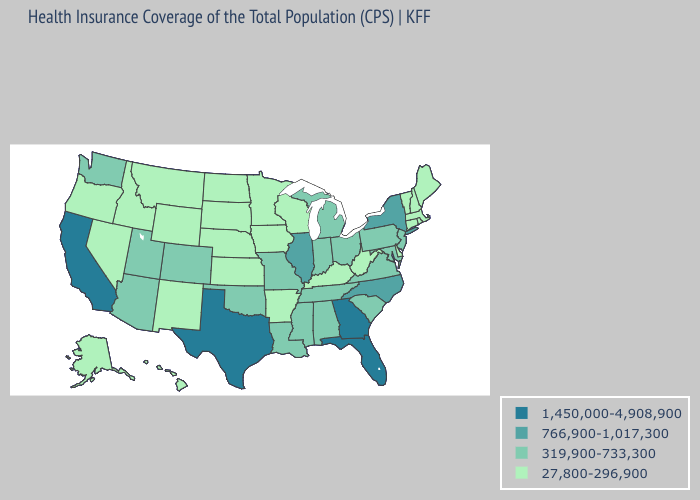Which states have the highest value in the USA?
Write a very short answer. California, Florida, Georgia, Texas. Name the states that have a value in the range 1,450,000-4,908,900?
Quick response, please. California, Florida, Georgia, Texas. What is the value of Mississippi?
Answer briefly. 319,900-733,300. What is the value of Wyoming?
Concise answer only. 27,800-296,900. What is the highest value in the USA?
Short answer required. 1,450,000-4,908,900. What is the lowest value in the USA?
Quick response, please. 27,800-296,900. What is the value of Connecticut?
Give a very brief answer. 27,800-296,900. Name the states that have a value in the range 1,450,000-4,908,900?
Be succinct. California, Florida, Georgia, Texas. Name the states that have a value in the range 766,900-1,017,300?
Short answer required. Illinois, New York, North Carolina. What is the value of Connecticut?
Be succinct. 27,800-296,900. What is the value of Louisiana?
Answer briefly. 319,900-733,300. What is the value of California?
Short answer required. 1,450,000-4,908,900. Does Hawaii have the lowest value in the West?
Keep it brief. Yes. How many symbols are there in the legend?
Concise answer only. 4. 